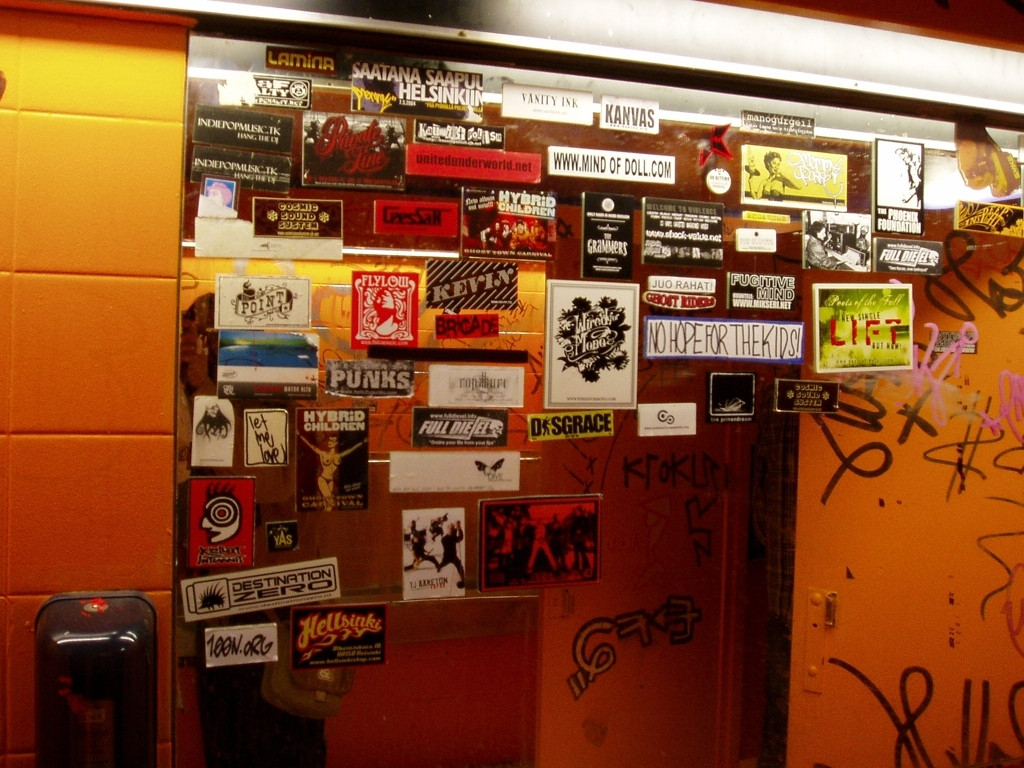Can you tell me about the different themes or subjects of the stickers in this image? The stickers in this image cover various themes that range from music and band promotion to social and political messages. Some stickers represent local or independent bands, music venues, and cultural events, indicating a strong local music scene. Others display slogans and artistic designs that are likely aligned with social causes, personal expression, or just a sense of humor. Each sticker contributes to a collage that reflects the diversity of thoughts and creativity within the community. 